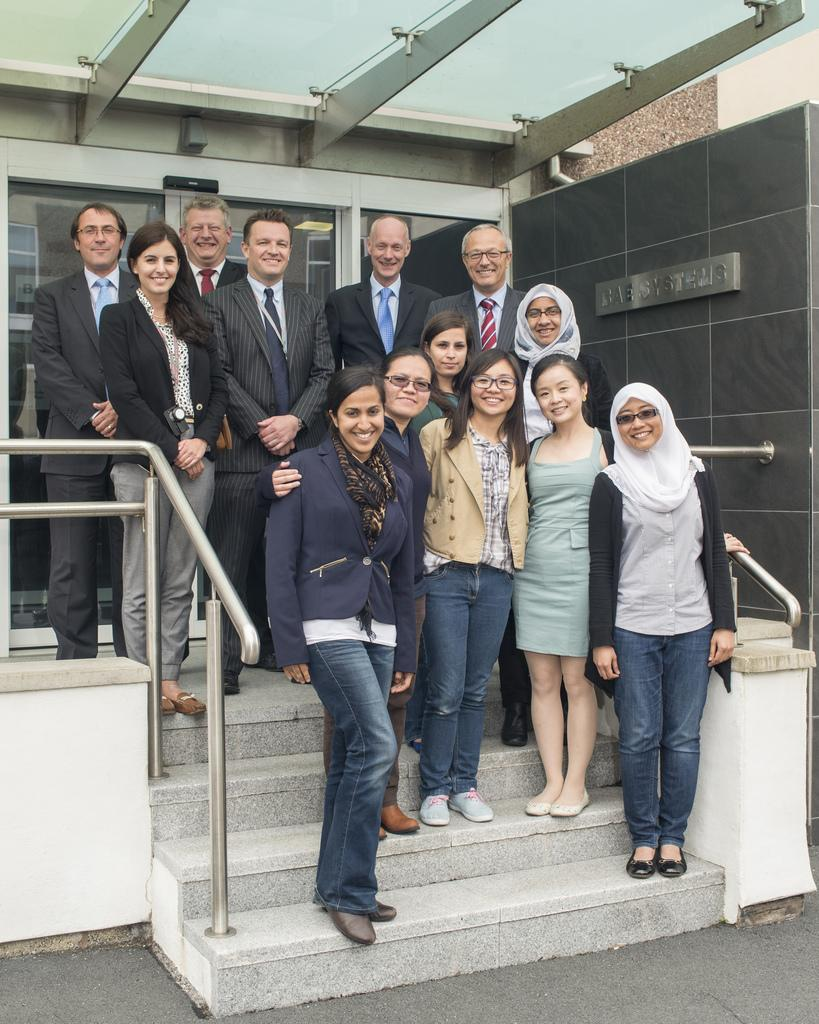How many people are in the image? There is a group of people in the image. Can you describe the clothing of one person in the group? One person in front is wearing a blue blazer and blue pants. What is visible in the background of the image? There is a glass door and a gray wall in the background of the image. What type of fuel is being used by the stitch in the image? There is no stitch or fuel present in the image. 